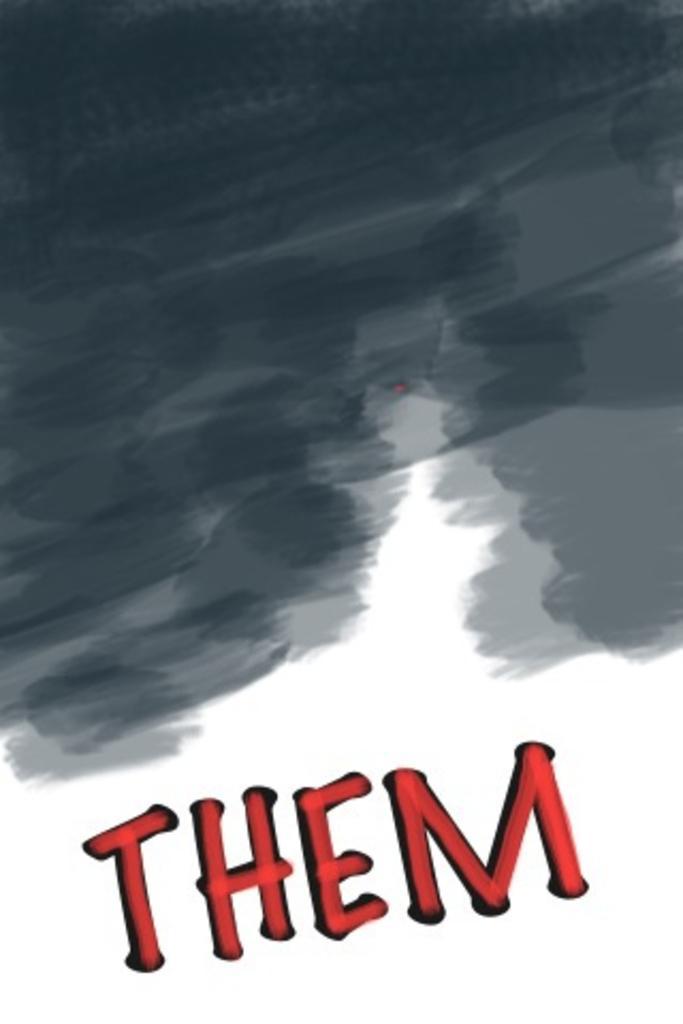How would you summarize this image in a sentence or two? In the foreground of this image, there is text at the bottom and the black color shade at the top. 